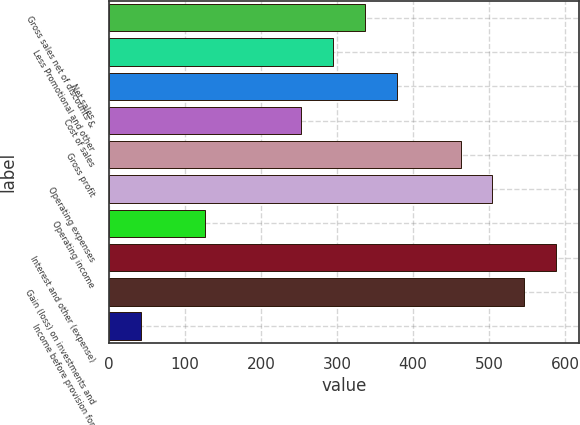<chart> <loc_0><loc_0><loc_500><loc_500><bar_chart><fcel>Gross sales net of discounts &<fcel>Less Promotional and other<fcel>Net sales<fcel>Cost of sales<fcel>Gross profit<fcel>Operating expenses<fcel>Operating income<fcel>Interest and other (expense)<fcel>Gain (loss) on investments and<fcel>Income before provision for<nl><fcel>336.32<fcel>294.33<fcel>378.31<fcel>252.34<fcel>462.29<fcel>504.28<fcel>126.37<fcel>588.26<fcel>546.27<fcel>42.39<nl></chart> 